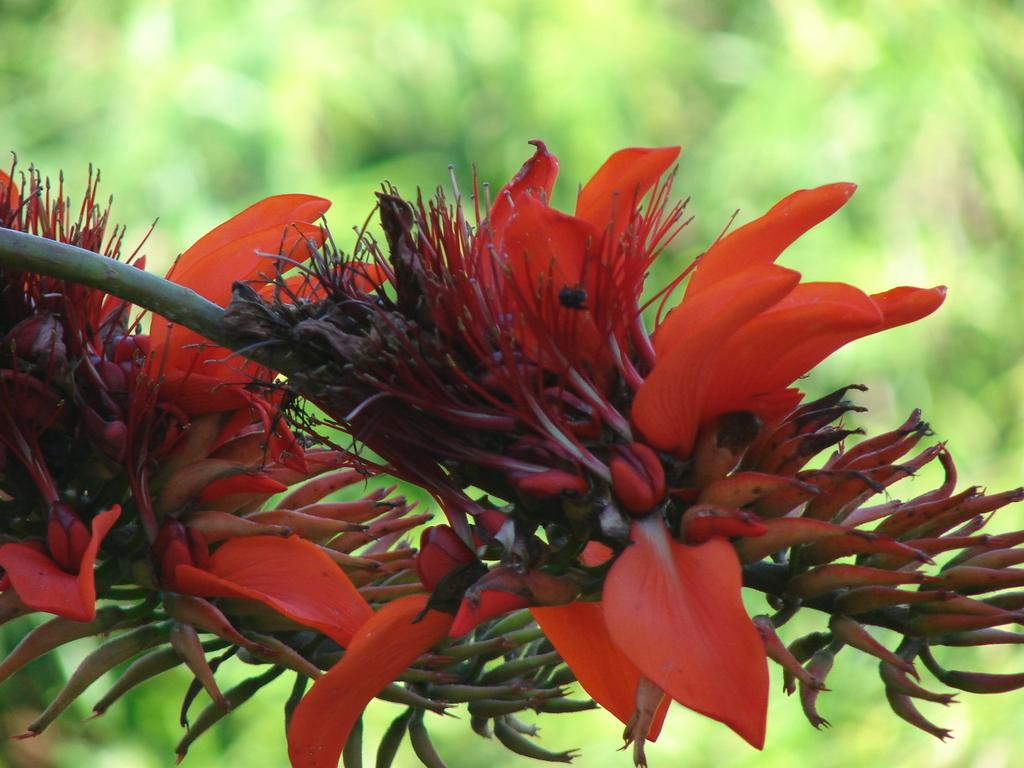What is located in the foreground of the image? There are flowers and stems in the foreground of the image. Can you describe the flowers in the image? The flowers are not specifically described in the facts, but they are present in the foreground. What can be seen in the background of the image? There is greenery in the background of the image. What type of comb is used to style the flowers in the image? There is no comb present in the image, as the flowers are not styled or groomed in any way. 